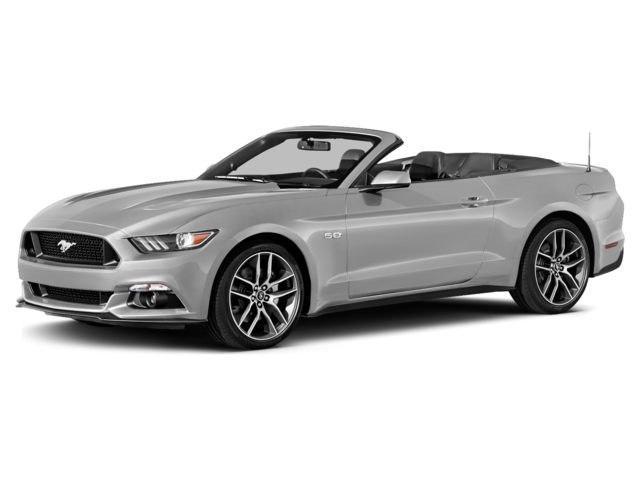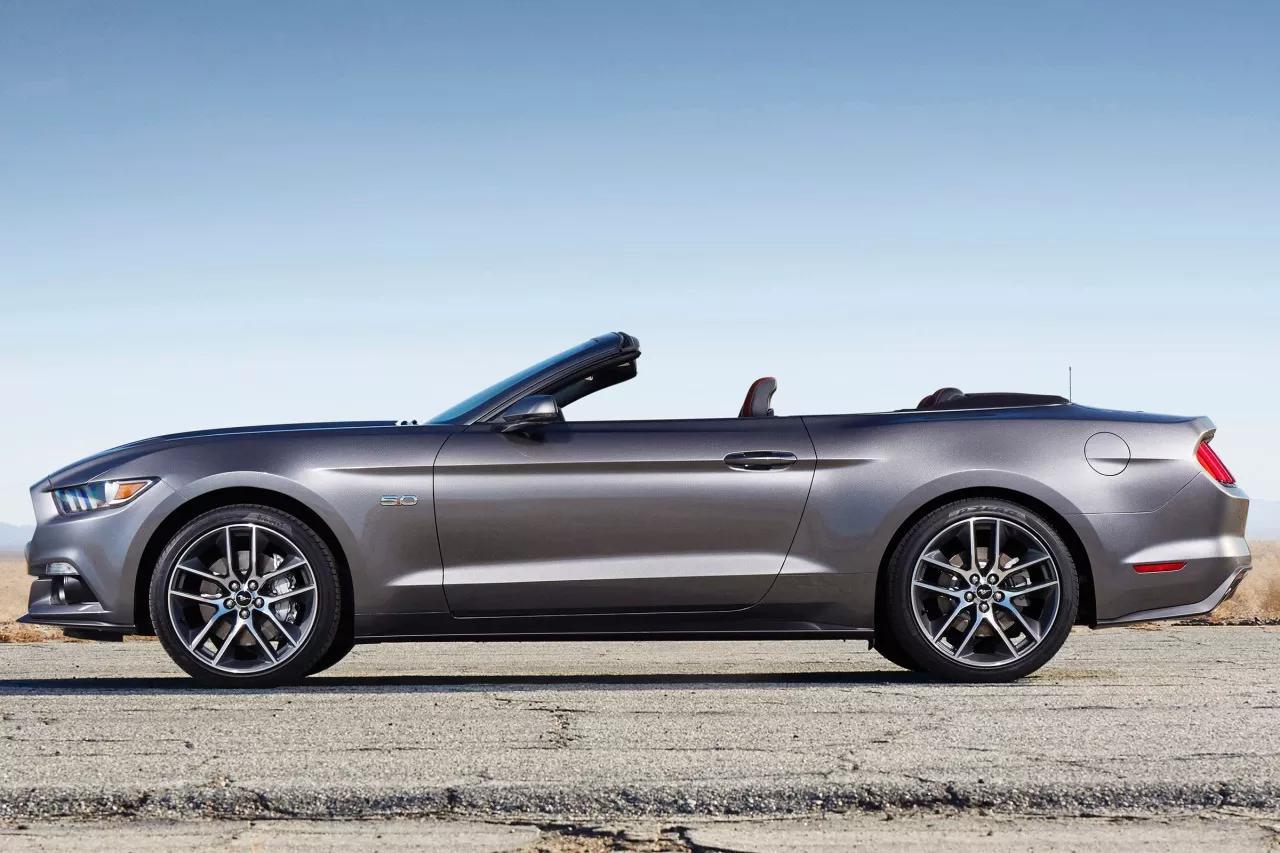The first image is the image on the left, the second image is the image on the right. Assess this claim about the two images: "All cars are facing left.". Correct or not? Answer yes or no. Yes. The first image is the image on the left, the second image is the image on the right. Assess this claim about the two images: "One convertible is angled towards the front and one is shown from the side.". Correct or not? Answer yes or no. Yes. 